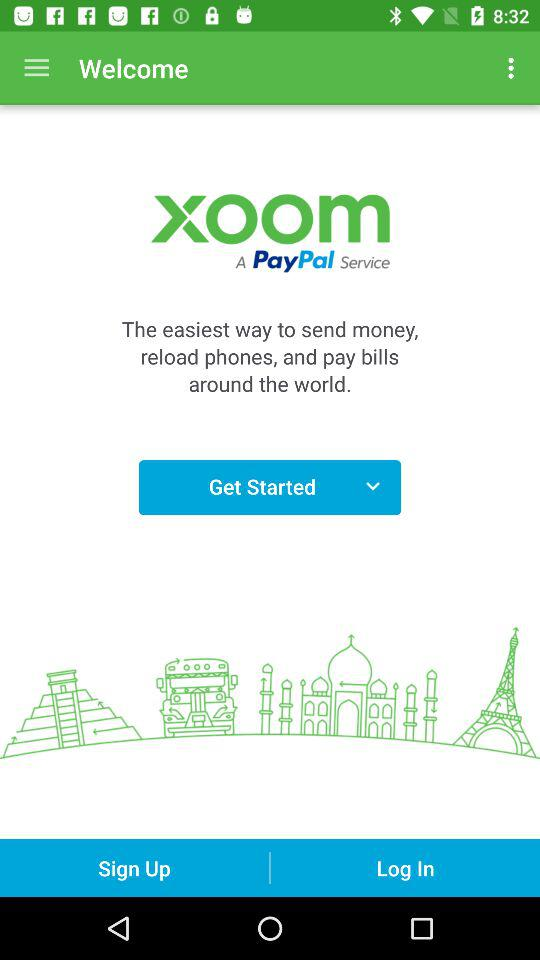What is the application name? The application name is "xoom". 